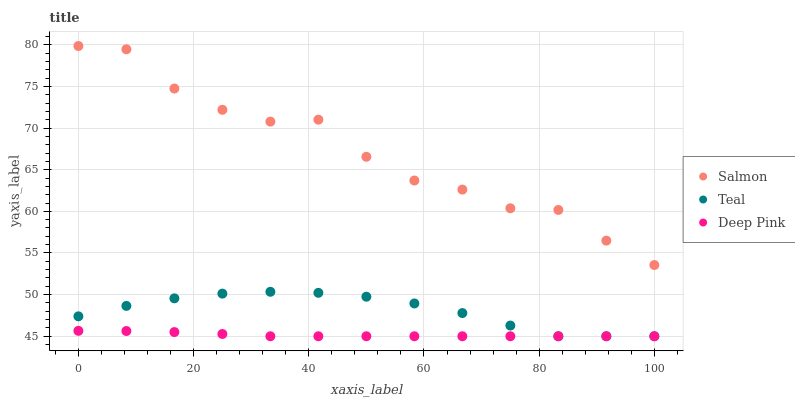Does Deep Pink have the minimum area under the curve?
Answer yes or no. Yes. Does Salmon have the maximum area under the curve?
Answer yes or no. Yes. Does Teal have the minimum area under the curve?
Answer yes or no. No. Does Teal have the maximum area under the curve?
Answer yes or no. No. Is Deep Pink the smoothest?
Answer yes or no. Yes. Is Salmon the roughest?
Answer yes or no. Yes. Is Teal the smoothest?
Answer yes or no. No. Is Teal the roughest?
Answer yes or no. No. Does Deep Pink have the lowest value?
Answer yes or no. Yes. Does Salmon have the lowest value?
Answer yes or no. No. Does Salmon have the highest value?
Answer yes or no. Yes. Does Teal have the highest value?
Answer yes or no. No. Is Teal less than Salmon?
Answer yes or no. Yes. Is Salmon greater than Teal?
Answer yes or no. Yes. Does Teal intersect Deep Pink?
Answer yes or no. Yes. Is Teal less than Deep Pink?
Answer yes or no. No. Is Teal greater than Deep Pink?
Answer yes or no. No. Does Teal intersect Salmon?
Answer yes or no. No. 